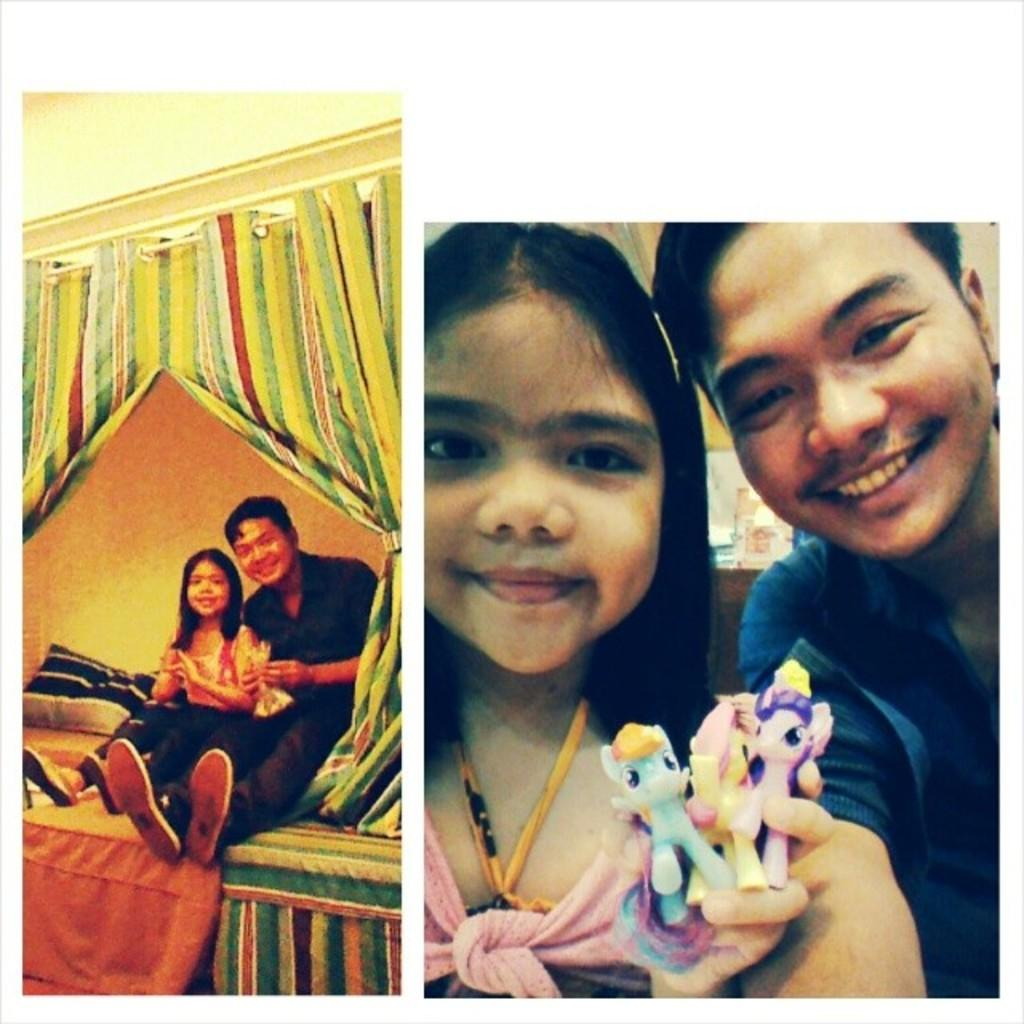What is the main subject of the photograph in the image? The main subject of the photograph is a boy and a girl. Where are the boy and girl located in the image? They are in a college setting. What are they holding in their hands? They are holding a small toy. What is their facial expression in the image? They are smiling. What are they doing in the photograph? They are posing for the camera. Can you tell me how many pieces of lumber are visible in the image? There is no lumber present in the image; it features a photograph of a boy and a girl in a college setting. What type of treatment is being administered to the boy and girl in the image? There is no treatment being administered to the boy and girl in the image; they are simply posing for a photograph. 